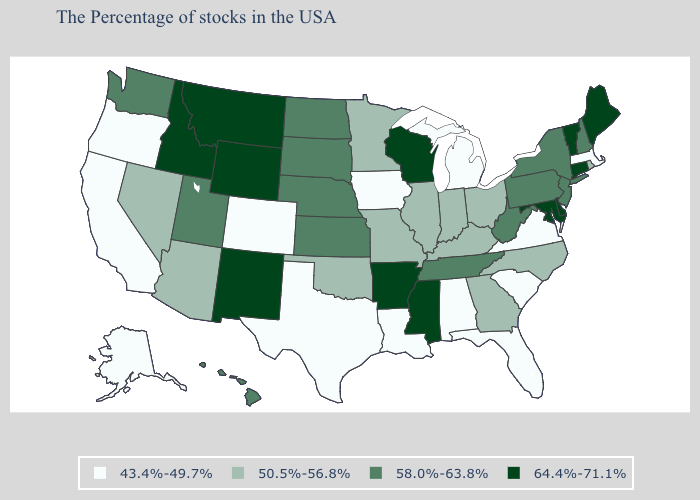What is the value of South Carolina?
Be succinct. 43.4%-49.7%. Does Illinois have the same value as New Mexico?
Quick response, please. No. Does Pennsylvania have the same value as South Dakota?
Answer briefly. Yes. Which states have the highest value in the USA?
Short answer required. Maine, Vermont, Connecticut, Delaware, Maryland, Wisconsin, Mississippi, Arkansas, Wyoming, New Mexico, Montana, Idaho. Which states have the lowest value in the USA?
Keep it brief. Massachusetts, Virginia, South Carolina, Florida, Michigan, Alabama, Louisiana, Iowa, Texas, Colorado, California, Oregon, Alaska. Does Montana have the same value as Alaska?
Answer briefly. No. What is the lowest value in states that border Colorado?
Quick response, please. 50.5%-56.8%. Does Nebraska have the lowest value in the USA?
Give a very brief answer. No. Does South Carolina have the lowest value in the USA?
Quick response, please. Yes. How many symbols are there in the legend?
Concise answer only. 4. How many symbols are there in the legend?
Write a very short answer. 4. What is the lowest value in states that border Maryland?
Short answer required. 43.4%-49.7%. What is the value of Colorado?
Short answer required. 43.4%-49.7%. What is the highest value in states that border Maine?
Quick response, please. 58.0%-63.8%. How many symbols are there in the legend?
Answer briefly. 4. 